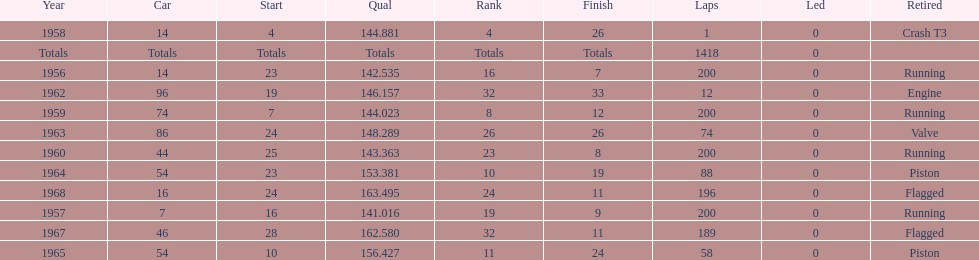What was its prime beginning position? 4. 